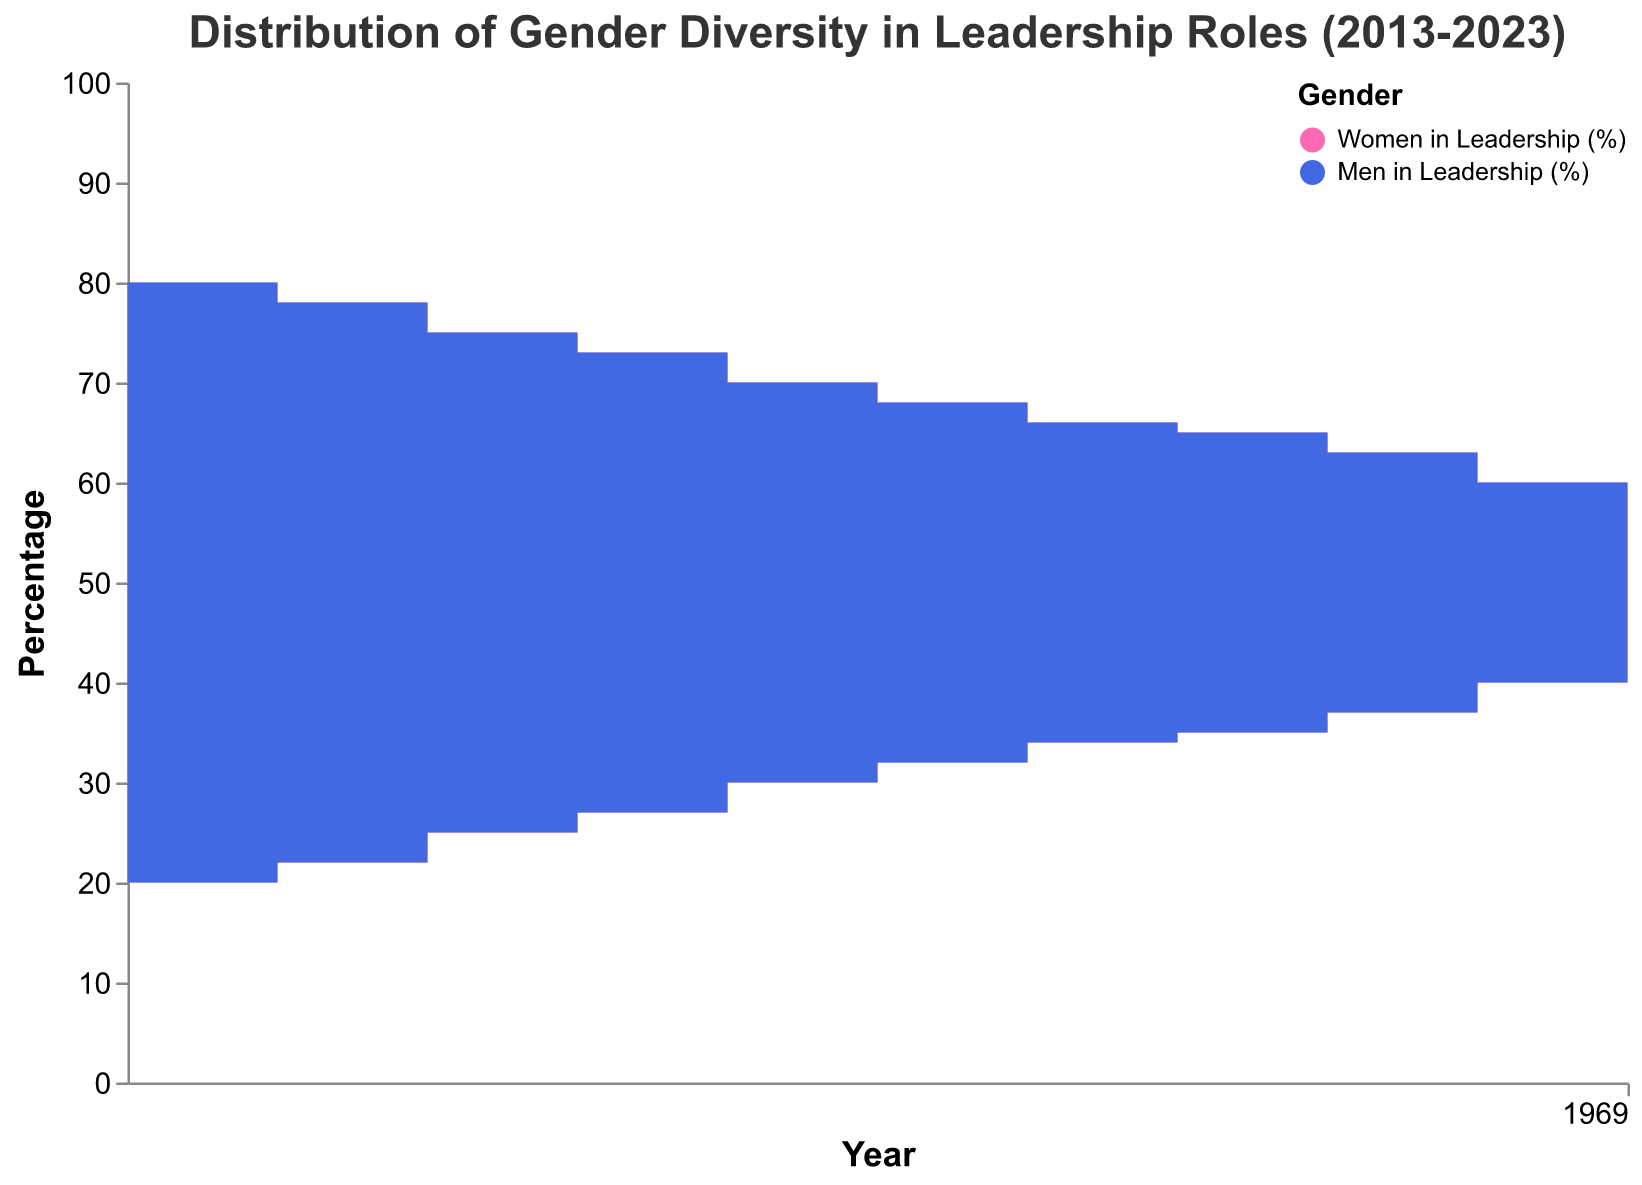How has the percentage of women in leadership roles changed from 2013 to 2023? The figure shows two step areas, the pink one represents women in leadership roles, indicating its increases over time. In 2013, it was 20%, and by 2023, it had risen to 42%.
Answer: From 20% to 42% What's the trend of men in leadership roles from 2013 to 2023 based on the figure? The blue step area represents men in leadership roles, showing a downward trend over the decade. It starts at 80% in 2013 and decreases to 58% by 2023.
Answer: Decreasing Which year shows the largest difference in the percentage of men and women in leadership roles? By looking at the figure, the largest difference is in 2013, where men were 80% and women were 20%, leading to a difference of 60%.
Answer: 2013 What percentage of leadership roles were held by women in 2017? Referring to the figure, the pink step area in 2017 indicates that women held 30% of the leadership roles.
Answer: 30% How many years did it take for the percentage of women in leadership roles to increase from 20% to 40%? The percentage of women in leadership roles grew from 20% in 2013 to 40% in 2022. This implies it took 9 years.
Answer: 9 years What's the combined percentage of men and women in leadership roles for the year 2020? The figure shows men at 65% and women at 35% in 2020. Adding these together gives a combined percentage of 100%.
Answer: 100% In which year did women first surpass 30% in leadership roles? Observing the pink step area, women first surpassed 30% in 2017, where they reached 32%.
Answer: 2017 Compare the percentage decrease of men in leadership roles from 2013 to 2020. From 2013 to 2020, men in leadership roles dropped from 80% to 65%. This is a 15 percentage points decrease over 7 years.
Answer: 15 percentage points Is there any year where the percentage of men and women in leadership roles are equal? Referring to the figure, there is no year where the areas for men and women align perfectly, meaning they were never equal during this period.
Answer: No What can you infer about gender diversity in leadership roles from the data shown in this step area chart? The pink and blue step areas indicate a progressive increase in gender diversity over the decade, with women's representation gradually rising while men's dominance decreases, suggesting efforts towards more balanced gender representation in leadership.
Answer: Increasing gender diversity 